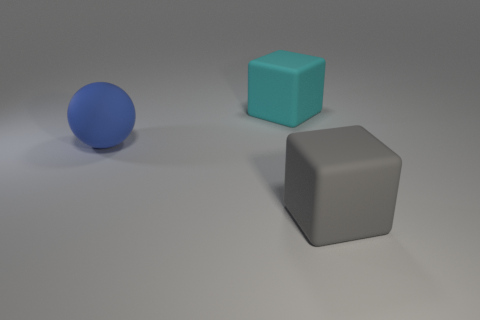Add 2 gray rubber things. How many objects exist? 5 Subtract all blocks. How many objects are left? 1 Add 1 big blue matte things. How many big blue matte things exist? 2 Subtract 0 red balls. How many objects are left? 3 Subtract all cyan shiny balls. Subtract all big cyan things. How many objects are left? 2 Add 3 large rubber spheres. How many large rubber spheres are left? 4 